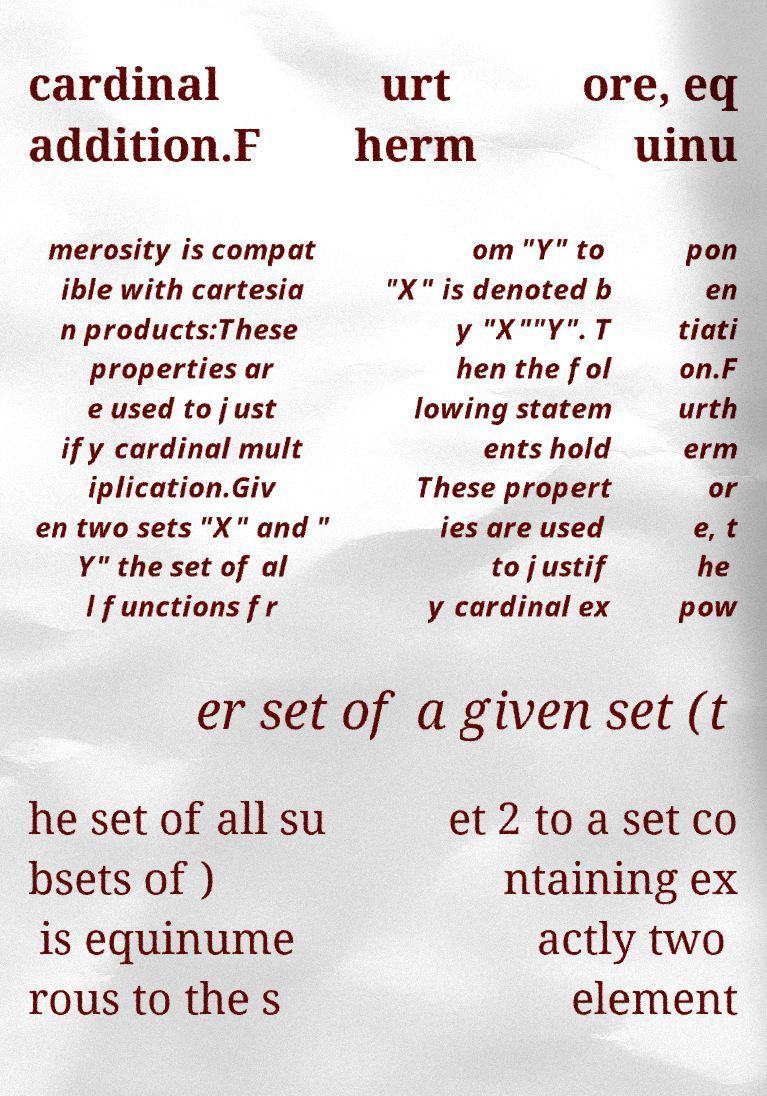Please identify and transcribe the text found in this image. cardinal addition.F urt herm ore, eq uinu merosity is compat ible with cartesia n products:These properties ar e used to just ify cardinal mult iplication.Giv en two sets "X" and " Y" the set of al l functions fr om "Y" to "X" is denoted b y "X""Y". T hen the fol lowing statem ents hold These propert ies are used to justif y cardinal ex pon en tiati on.F urth erm or e, t he pow er set of a given set (t he set of all su bsets of ) is equinume rous to the s et 2 to a set co ntaining ex actly two element 